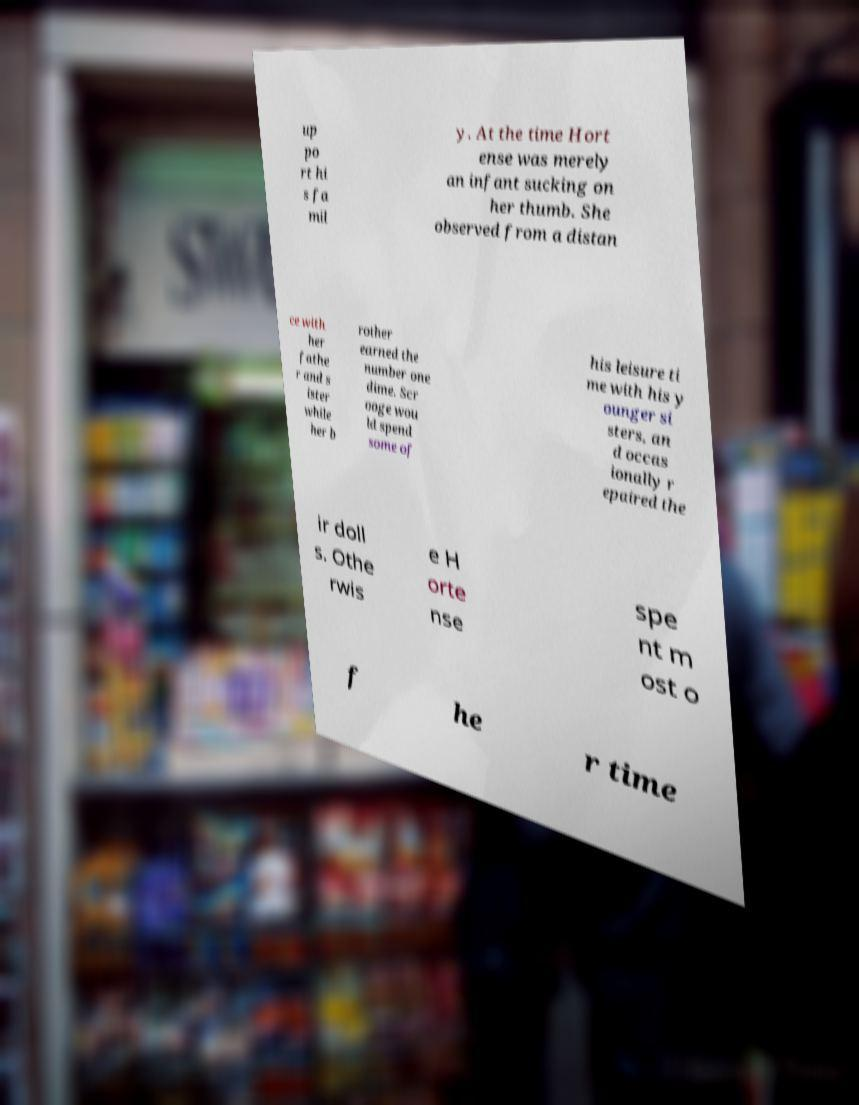What messages or text are displayed in this image? I need them in a readable, typed format. up po rt hi s fa mil y. At the time Hort ense was merely an infant sucking on her thumb. She observed from a distan ce with her fathe r and s ister while her b rother earned the number one dime. Scr ooge wou ld spend some of his leisure ti me with his y ounger si sters, an d occas ionally r epaired the ir doll s. Othe rwis e H orte nse spe nt m ost o f he r time 